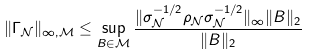<formula> <loc_0><loc_0><loc_500><loc_500>\| \Gamma _ { \mathcal { N } } \| _ { \infty , \mathcal { M } } \leq \sup _ { B \in \mathcal { M } } \frac { \| \sigma _ { \mathcal { N } } ^ { - 1 / 2 } \rho _ { \mathcal { N } } \sigma _ { \mathcal { N } } ^ { - 1 / 2 } \| _ { \infty } \| B \| _ { 2 } } { \| B \| _ { 2 } }</formula> 